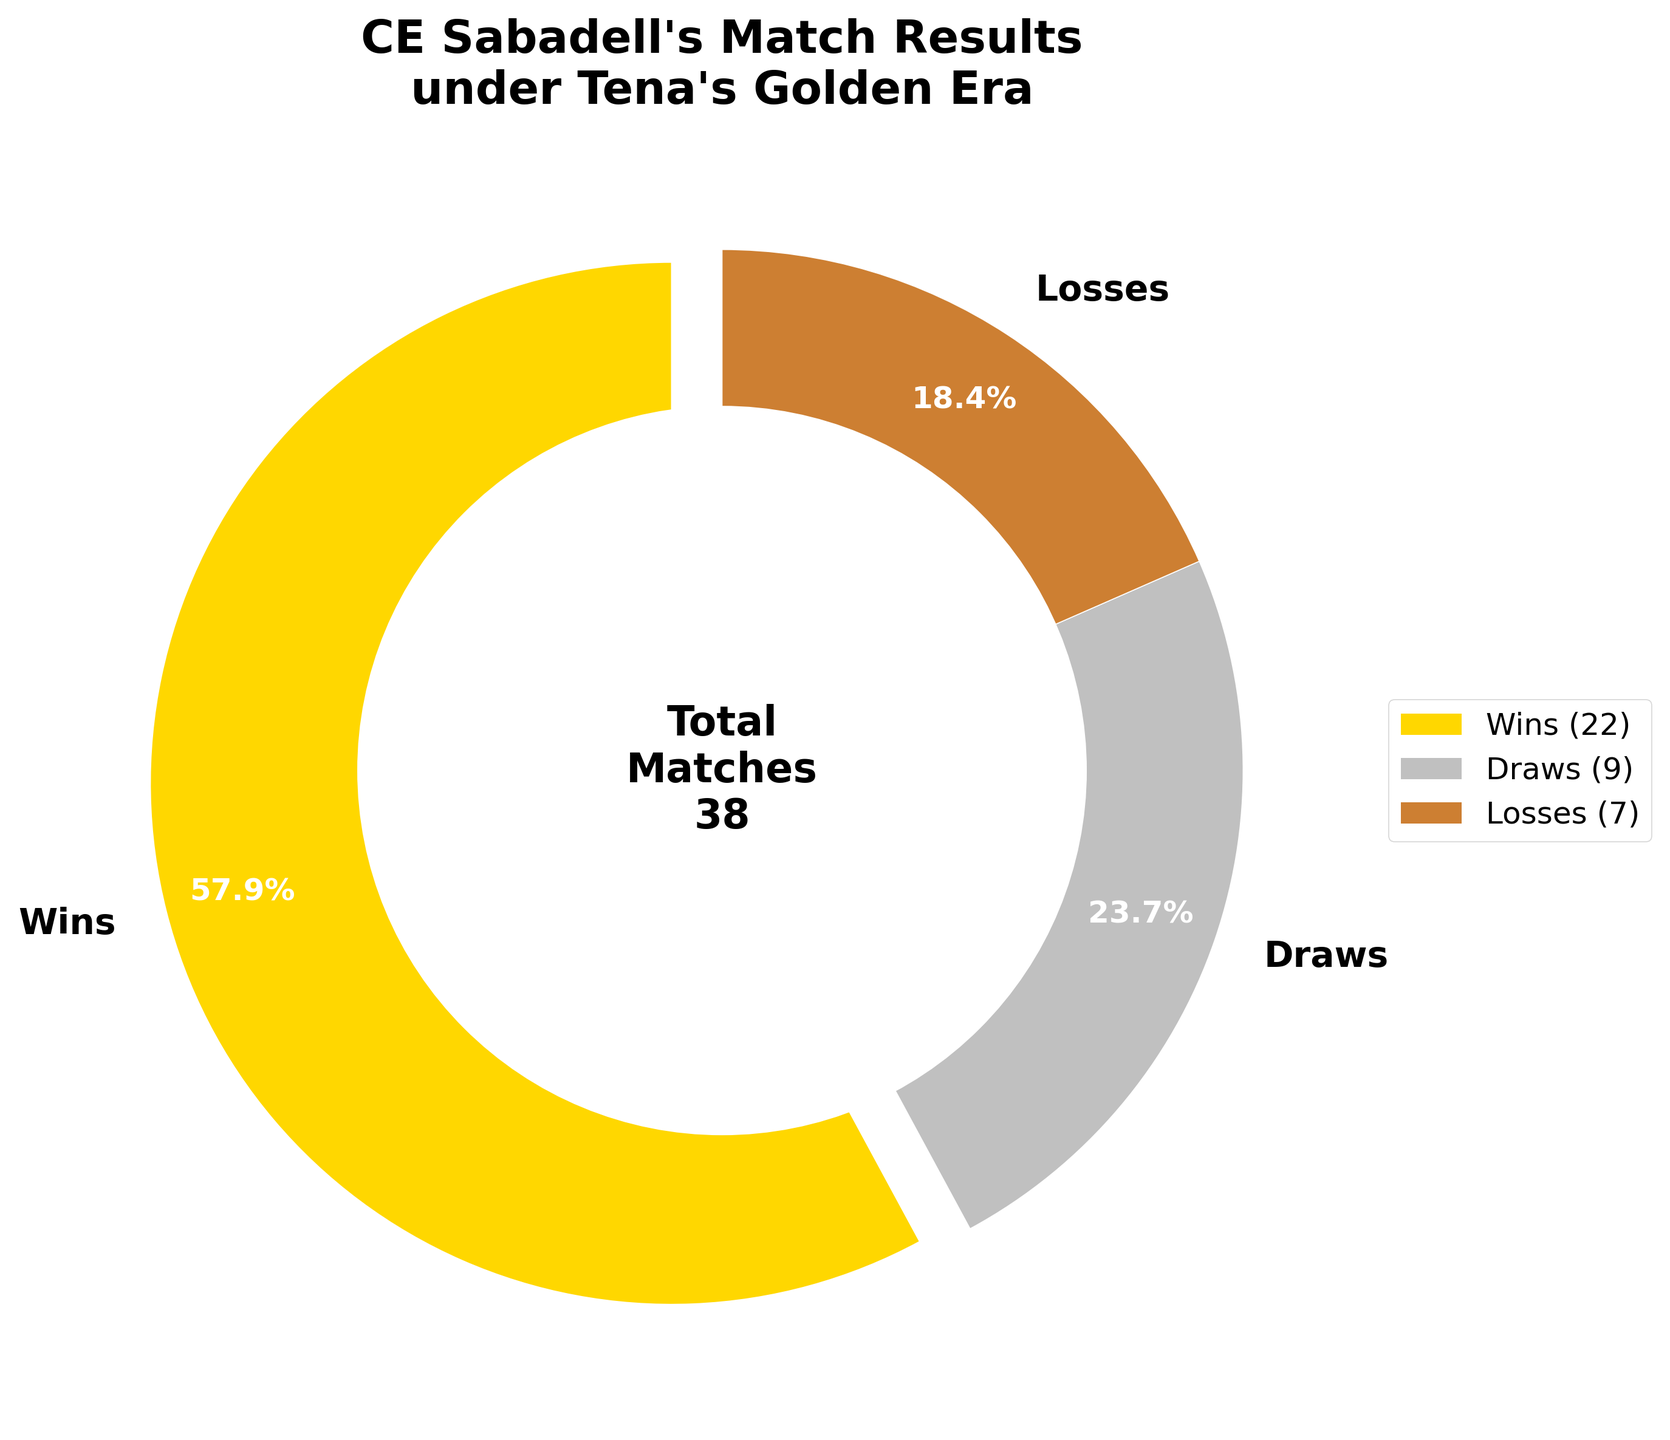What percentage of matches did CE Sabadell win in their most successful season under Tena? Observing the pie chart, the "Wins" section indicates 22 matches and is auto-labeled with a percentage. This percentage is displayed as 55.0%.
Answer: 55.0% How many more wins than losses did CE Sabadell have in that season? The pie chart shows 22 wins and 7 losses. To find the difference, subtract the number of losses from the number of wins: 22 - 7 = 15.
Answer: 15 Which result category had the second highest number of matches? The pie chart sections are labeled with match results and their respective counts: Wins (22), Draws (9), and Losses (7). The second highest is Draws with 9 matches.
Answer: Draws What is the total number of matches played by CE Sabadell in their most successful season under Tena? The pie chart title specifies the total matches and the center text reiterates it as 38. Adding individual matches also sums to: 22 + 9 + 7 = 38.
Answer: 38 If the number of losses doubled, what percentage of the total matches would they represent? If losses doubled, it would be 7 * 2 = 14. The total number of matches would be: 22 (Wins) + 9 (Draws) + 14 (Losses) = 45. The new percentage for losses is (14/45) * 100 ≈ 31.1%.
Answer: 31.1% What color represents the highest number of matches outcome? The section representing 22 wins is the largest and is colored gold.
Answer: Gold How much smaller is the number of draws compared to the total number of matches? The total number of matches is 38. Subtracting the number of draws gives: 38 - 9 = 29.
Answer: 29 What fraction of the total matches did CE Sabadell draw? The pie chart shows 9 draws out of 38 matches. The fraction is 9/38. Simplifying this: divide both numerator and denominator by their GCD which is 1, so the answer remains 9/38.
Answer: 9/38 